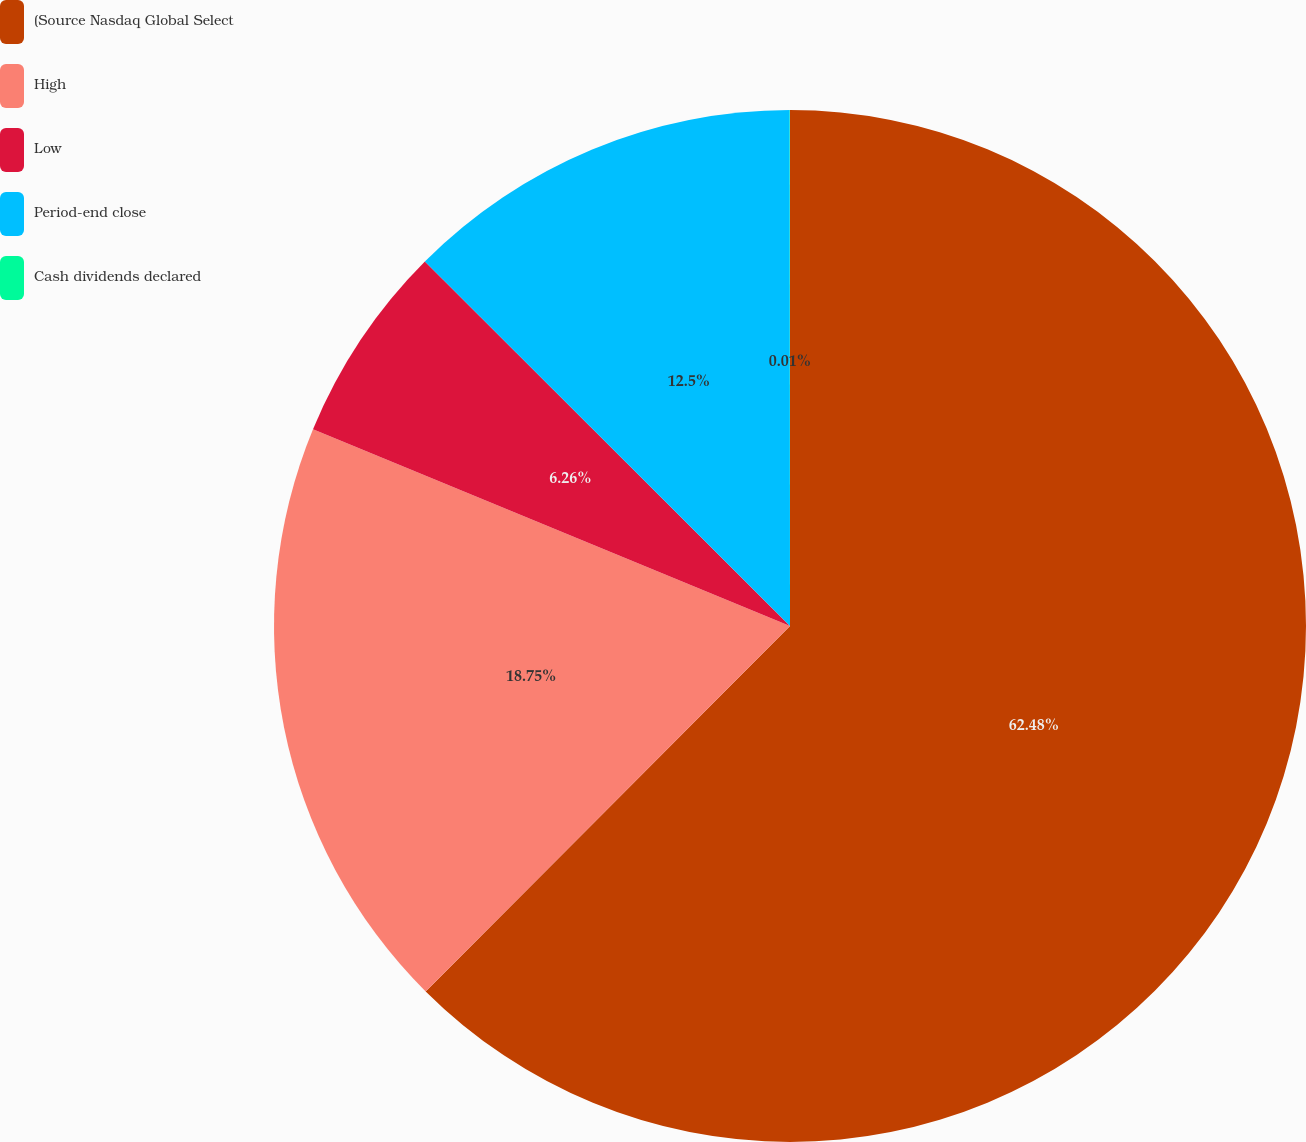Convert chart to OTSL. <chart><loc_0><loc_0><loc_500><loc_500><pie_chart><fcel>(Source Nasdaq Global Select<fcel>High<fcel>Low<fcel>Period-end close<fcel>Cash dividends declared<nl><fcel>62.47%<fcel>18.75%<fcel>6.26%<fcel>12.5%<fcel>0.01%<nl></chart> 